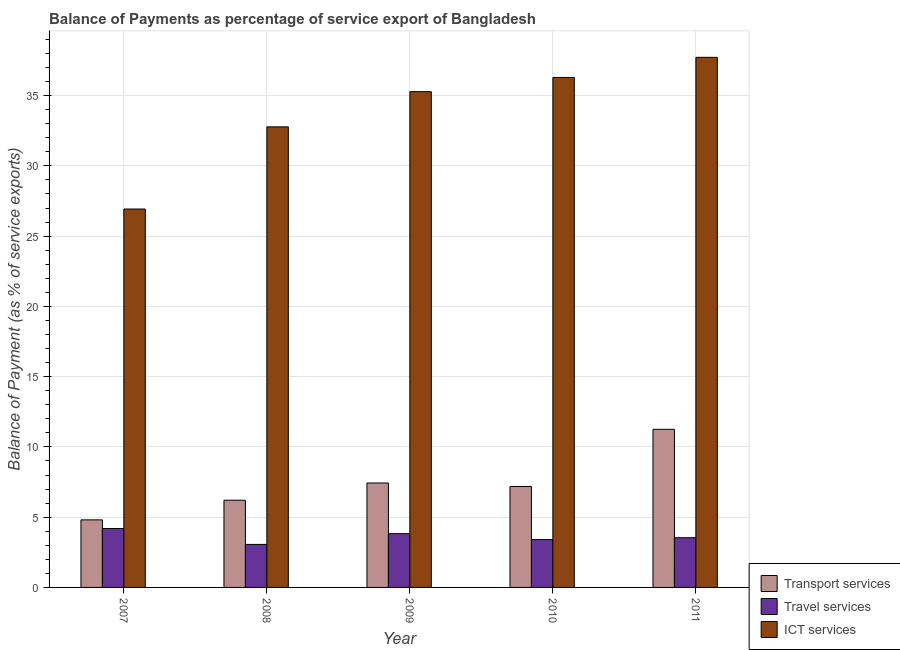Are the number of bars per tick equal to the number of legend labels?
Keep it short and to the point. Yes. How many bars are there on the 2nd tick from the left?
Your answer should be compact. 3. In how many cases, is the number of bars for a given year not equal to the number of legend labels?
Provide a short and direct response. 0. What is the balance of payment of travel services in 2010?
Keep it short and to the point. 3.4. Across all years, what is the maximum balance of payment of ict services?
Offer a very short reply. 37.73. Across all years, what is the minimum balance of payment of transport services?
Provide a succinct answer. 4.81. In which year was the balance of payment of travel services maximum?
Your answer should be compact. 2007. In which year was the balance of payment of ict services minimum?
Your response must be concise. 2007. What is the total balance of payment of ict services in the graph?
Make the answer very short. 169.01. What is the difference between the balance of payment of ict services in 2009 and that in 2011?
Ensure brevity in your answer.  -2.44. What is the difference between the balance of payment of travel services in 2010 and the balance of payment of ict services in 2011?
Make the answer very short. -0.13. What is the average balance of payment of ict services per year?
Your answer should be very brief. 33.8. In the year 2007, what is the difference between the balance of payment of ict services and balance of payment of travel services?
Provide a succinct answer. 0. In how many years, is the balance of payment of ict services greater than 33 %?
Provide a succinct answer. 3. What is the ratio of the balance of payment of transport services in 2008 to that in 2011?
Ensure brevity in your answer.  0.55. Is the difference between the balance of payment of transport services in 2007 and 2009 greater than the difference between the balance of payment of travel services in 2007 and 2009?
Make the answer very short. No. What is the difference between the highest and the second highest balance of payment of ict services?
Your response must be concise. 1.43. What is the difference between the highest and the lowest balance of payment of transport services?
Keep it short and to the point. 6.44. Is the sum of the balance of payment of ict services in 2007 and 2010 greater than the maximum balance of payment of travel services across all years?
Offer a very short reply. Yes. What does the 2nd bar from the left in 2009 represents?
Give a very brief answer. Travel services. What does the 2nd bar from the right in 2009 represents?
Your response must be concise. Travel services. How many years are there in the graph?
Provide a short and direct response. 5. Are the values on the major ticks of Y-axis written in scientific E-notation?
Provide a short and direct response. No. Does the graph contain any zero values?
Provide a succinct answer. No. Does the graph contain grids?
Your response must be concise. Yes. How many legend labels are there?
Offer a very short reply. 3. What is the title of the graph?
Your answer should be very brief. Balance of Payments as percentage of service export of Bangladesh. What is the label or title of the X-axis?
Your answer should be very brief. Year. What is the label or title of the Y-axis?
Keep it short and to the point. Balance of Payment (as % of service exports). What is the Balance of Payment (as % of service exports) in Transport services in 2007?
Your answer should be compact. 4.81. What is the Balance of Payment (as % of service exports) of Travel services in 2007?
Provide a short and direct response. 4.19. What is the Balance of Payment (as % of service exports) in ICT services in 2007?
Provide a short and direct response. 26.93. What is the Balance of Payment (as % of service exports) in Transport services in 2008?
Your answer should be very brief. 6.21. What is the Balance of Payment (as % of service exports) of Travel services in 2008?
Ensure brevity in your answer.  3.06. What is the Balance of Payment (as % of service exports) in ICT services in 2008?
Your response must be concise. 32.78. What is the Balance of Payment (as % of service exports) in Transport services in 2009?
Keep it short and to the point. 7.43. What is the Balance of Payment (as % of service exports) of Travel services in 2009?
Your answer should be compact. 3.83. What is the Balance of Payment (as % of service exports) of ICT services in 2009?
Give a very brief answer. 35.28. What is the Balance of Payment (as % of service exports) in Transport services in 2010?
Your answer should be compact. 7.19. What is the Balance of Payment (as % of service exports) in Travel services in 2010?
Ensure brevity in your answer.  3.4. What is the Balance of Payment (as % of service exports) in ICT services in 2010?
Make the answer very short. 36.29. What is the Balance of Payment (as % of service exports) in Transport services in 2011?
Keep it short and to the point. 11.25. What is the Balance of Payment (as % of service exports) in Travel services in 2011?
Give a very brief answer. 3.54. What is the Balance of Payment (as % of service exports) in ICT services in 2011?
Provide a succinct answer. 37.73. Across all years, what is the maximum Balance of Payment (as % of service exports) of Transport services?
Give a very brief answer. 11.25. Across all years, what is the maximum Balance of Payment (as % of service exports) of Travel services?
Provide a succinct answer. 4.19. Across all years, what is the maximum Balance of Payment (as % of service exports) of ICT services?
Your answer should be compact. 37.73. Across all years, what is the minimum Balance of Payment (as % of service exports) of Transport services?
Make the answer very short. 4.81. Across all years, what is the minimum Balance of Payment (as % of service exports) in Travel services?
Provide a short and direct response. 3.06. Across all years, what is the minimum Balance of Payment (as % of service exports) of ICT services?
Ensure brevity in your answer.  26.93. What is the total Balance of Payment (as % of service exports) of Transport services in the graph?
Your response must be concise. 36.88. What is the total Balance of Payment (as % of service exports) of Travel services in the graph?
Your response must be concise. 18.02. What is the total Balance of Payment (as % of service exports) in ICT services in the graph?
Make the answer very short. 169.01. What is the difference between the Balance of Payment (as % of service exports) in Transport services in 2007 and that in 2008?
Offer a very short reply. -1.4. What is the difference between the Balance of Payment (as % of service exports) in Travel services in 2007 and that in 2008?
Offer a terse response. 1.13. What is the difference between the Balance of Payment (as % of service exports) of ICT services in 2007 and that in 2008?
Provide a short and direct response. -5.85. What is the difference between the Balance of Payment (as % of service exports) of Transport services in 2007 and that in 2009?
Keep it short and to the point. -2.62. What is the difference between the Balance of Payment (as % of service exports) of Travel services in 2007 and that in 2009?
Offer a terse response. 0.37. What is the difference between the Balance of Payment (as % of service exports) in ICT services in 2007 and that in 2009?
Provide a short and direct response. -8.35. What is the difference between the Balance of Payment (as % of service exports) of Transport services in 2007 and that in 2010?
Offer a terse response. -2.38. What is the difference between the Balance of Payment (as % of service exports) of Travel services in 2007 and that in 2010?
Keep it short and to the point. 0.79. What is the difference between the Balance of Payment (as % of service exports) of ICT services in 2007 and that in 2010?
Keep it short and to the point. -9.37. What is the difference between the Balance of Payment (as % of service exports) of Transport services in 2007 and that in 2011?
Your response must be concise. -6.45. What is the difference between the Balance of Payment (as % of service exports) in Travel services in 2007 and that in 2011?
Ensure brevity in your answer.  0.66. What is the difference between the Balance of Payment (as % of service exports) of ICT services in 2007 and that in 2011?
Provide a succinct answer. -10.8. What is the difference between the Balance of Payment (as % of service exports) of Transport services in 2008 and that in 2009?
Offer a very short reply. -1.23. What is the difference between the Balance of Payment (as % of service exports) of Travel services in 2008 and that in 2009?
Give a very brief answer. -0.77. What is the difference between the Balance of Payment (as % of service exports) in ICT services in 2008 and that in 2009?
Offer a very short reply. -2.51. What is the difference between the Balance of Payment (as % of service exports) in Transport services in 2008 and that in 2010?
Ensure brevity in your answer.  -0.98. What is the difference between the Balance of Payment (as % of service exports) in Travel services in 2008 and that in 2010?
Ensure brevity in your answer.  -0.34. What is the difference between the Balance of Payment (as % of service exports) in ICT services in 2008 and that in 2010?
Offer a terse response. -3.52. What is the difference between the Balance of Payment (as % of service exports) of Transport services in 2008 and that in 2011?
Provide a succinct answer. -5.05. What is the difference between the Balance of Payment (as % of service exports) in Travel services in 2008 and that in 2011?
Your answer should be compact. -0.48. What is the difference between the Balance of Payment (as % of service exports) of ICT services in 2008 and that in 2011?
Ensure brevity in your answer.  -4.95. What is the difference between the Balance of Payment (as % of service exports) of Transport services in 2009 and that in 2010?
Your answer should be compact. 0.25. What is the difference between the Balance of Payment (as % of service exports) of Travel services in 2009 and that in 2010?
Make the answer very short. 0.42. What is the difference between the Balance of Payment (as % of service exports) in ICT services in 2009 and that in 2010?
Provide a short and direct response. -1.01. What is the difference between the Balance of Payment (as % of service exports) of Transport services in 2009 and that in 2011?
Provide a short and direct response. -3.82. What is the difference between the Balance of Payment (as % of service exports) in Travel services in 2009 and that in 2011?
Ensure brevity in your answer.  0.29. What is the difference between the Balance of Payment (as % of service exports) of ICT services in 2009 and that in 2011?
Give a very brief answer. -2.44. What is the difference between the Balance of Payment (as % of service exports) of Transport services in 2010 and that in 2011?
Your answer should be very brief. -4.07. What is the difference between the Balance of Payment (as % of service exports) of Travel services in 2010 and that in 2011?
Make the answer very short. -0.13. What is the difference between the Balance of Payment (as % of service exports) of ICT services in 2010 and that in 2011?
Provide a short and direct response. -1.43. What is the difference between the Balance of Payment (as % of service exports) of Transport services in 2007 and the Balance of Payment (as % of service exports) of Travel services in 2008?
Provide a succinct answer. 1.75. What is the difference between the Balance of Payment (as % of service exports) in Transport services in 2007 and the Balance of Payment (as % of service exports) in ICT services in 2008?
Provide a short and direct response. -27.97. What is the difference between the Balance of Payment (as % of service exports) of Travel services in 2007 and the Balance of Payment (as % of service exports) of ICT services in 2008?
Your answer should be very brief. -28.58. What is the difference between the Balance of Payment (as % of service exports) in Transport services in 2007 and the Balance of Payment (as % of service exports) in Travel services in 2009?
Your response must be concise. 0.98. What is the difference between the Balance of Payment (as % of service exports) of Transport services in 2007 and the Balance of Payment (as % of service exports) of ICT services in 2009?
Your answer should be compact. -30.48. What is the difference between the Balance of Payment (as % of service exports) of Travel services in 2007 and the Balance of Payment (as % of service exports) of ICT services in 2009?
Offer a terse response. -31.09. What is the difference between the Balance of Payment (as % of service exports) in Transport services in 2007 and the Balance of Payment (as % of service exports) in Travel services in 2010?
Offer a very short reply. 1.4. What is the difference between the Balance of Payment (as % of service exports) of Transport services in 2007 and the Balance of Payment (as % of service exports) of ICT services in 2010?
Offer a very short reply. -31.49. What is the difference between the Balance of Payment (as % of service exports) in Travel services in 2007 and the Balance of Payment (as % of service exports) in ICT services in 2010?
Provide a succinct answer. -32.1. What is the difference between the Balance of Payment (as % of service exports) of Transport services in 2007 and the Balance of Payment (as % of service exports) of Travel services in 2011?
Your answer should be compact. 1.27. What is the difference between the Balance of Payment (as % of service exports) in Transport services in 2007 and the Balance of Payment (as % of service exports) in ICT services in 2011?
Your answer should be very brief. -32.92. What is the difference between the Balance of Payment (as % of service exports) in Travel services in 2007 and the Balance of Payment (as % of service exports) in ICT services in 2011?
Offer a terse response. -33.53. What is the difference between the Balance of Payment (as % of service exports) in Transport services in 2008 and the Balance of Payment (as % of service exports) in Travel services in 2009?
Your answer should be very brief. 2.38. What is the difference between the Balance of Payment (as % of service exports) in Transport services in 2008 and the Balance of Payment (as % of service exports) in ICT services in 2009?
Offer a terse response. -29.08. What is the difference between the Balance of Payment (as % of service exports) in Travel services in 2008 and the Balance of Payment (as % of service exports) in ICT services in 2009?
Offer a terse response. -32.22. What is the difference between the Balance of Payment (as % of service exports) of Transport services in 2008 and the Balance of Payment (as % of service exports) of Travel services in 2010?
Offer a terse response. 2.8. What is the difference between the Balance of Payment (as % of service exports) of Transport services in 2008 and the Balance of Payment (as % of service exports) of ICT services in 2010?
Give a very brief answer. -30.09. What is the difference between the Balance of Payment (as % of service exports) in Travel services in 2008 and the Balance of Payment (as % of service exports) in ICT services in 2010?
Make the answer very short. -33.23. What is the difference between the Balance of Payment (as % of service exports) in Transport services in 2008 and the Balance of Payment (as % of service exports) in Travel services in 2011?
Keep it short and to the point. 2.67. What is the difference between the Balance of Payment (as % of service exports) in Transport services in 2008 and the Balance of Payment (as % of service exports) in ICT services in 2011?
Your answer should be compact. -31.52. What is the difference between the Balance of Payment (as % of service exports) of Travel services in 2008 and the Balance of Payment (as % of service exports) of ICT services in 2011?
Make the answer very short. -34.66. What is the difference between the Balance of Payment (as % of service exports) in Transport services in 2009 and the Balance of Payment (as % of service exports) in Travel services in 2010?
Offer a very short reply. 4.03. What is the difference between the Balance of Payment (as % of service exports) in Transport services in 2009 and the Balance of Payment (as % of service exports) in ICT services in 2010?
Provide a short and direct response. -28.86. What is the difference between the Balance of Payment (as % of service exports) of Travel services in 2009 and the Balance of Payment (as % of service exports) of ICT services in 2010?
Make the answer very short. -32.47. What is the difference between the Balance of Payment (as % of service exports) of Transport services in 2009 and the Balance of Payment (as % of service exports) of Travel services in 2011?
Your response must be concise. 3.9. What is the difference between the Balance of Payment (as % of service exports) in Transport services in 2009 and the Balance of Payment (as % of service exports) in ICT services in 2011?
Ensure brevity in your answer.  -30.29. What is the difference between the Balance of Payment (as % of service exports) of Travel services in 2009 and the Balance of Payment (as % of service exports) of ICT services in 2011?
Give a very brief answer. -33.9. What is the difference between the Balance of Payment (as % of service exports) of Transport services in 2010 and the Balance of Payment (as % of service exports) of Travel services in 2011?
Give a very brief answer. 3.65. What is the difference between the Balance of Payment (as % of service exports) in Transport services in 2010 and the Balance of Payment (as % of service exports) in ICT services in 2011?
Offer a very short reply. -30.54. What is the difference between the Balance of Payment (as % of service exports) in Travel services in 2010 and the Balance of Payment (as % of service exports) in ICT services in 2011?
Make the answer very short. -34.32. What is the average Balance of Payment (as % of service exports) in Transport services per year?
Ensure brevity in your answer.  7.38. What is the average Balance of Payment (as % of service exports) in Travel services per year?
Give a very brief answer. 3.6. What is the average Balance of Payment (as % of service exports) in ICT services per year?
Give a very brief answer. 33.8. In the year 2007, what is the difference between the Balance of Payment (as % of service exports) in Transport services and Balance of Payment (as % of service exports) in Travel services?
Your answer should be compact. 0.62. In the year 2007, what is the difference between the Balance of Payment (as % of service exports) in Transport services and Balance of Payment (as % of service exports) in ICT services?
Make the answer very short. -22.12. In the year 2007, what is the difference between the Balance of Payment (as % of service exports) of Travel services and Balance of Payment (as % of service exports) of ICT services?
Ensure brevity in your answer.  -22.74. In the year 2008, what is the difference between the Balance of Payment (as % of service exports) in Transport services and Balance of Payment (as % of service exports) in Travel services?
Provide a short and direct response. 3.14. In the year 2008, what is the difference between the Balance of Payment (as % of service exports) of Transport services and Balance of Payment (as % of service exports) of ICT services?
Make the answer very short. -26.57. In the year 2008, what is the difference between the Balance of Payment (as % of service exports) in Travel services and Balance of Payment (as % of service exports) in ICT services?
Your response must be concise. -29.72. In the year 2009, what is the difference between the Balance of Payment (as % of service exports) of Transport services and Balance of Payment (as % of service exports) of Travel services?
Your answer should be very brief. 3.61. In the year 2009, what is the difference between the Balance of Payment (as % of service exports) in Transport services and Balance of Payment (as % of service exports) in ICT services?
Give a very brief answer. -27.85. In the year 2009, what is the difference between the Balance of Payment (as % of service exports) in Travel services and Balance of Payment (as % of service exports) in ICT services?
Offer a terse response. -31.46. In the year 2010, what is the difference between the Balance of Payment (as % of service exports) in Transport services and Balance of Payment (as % of service exports) in Travel services?
Offer a terse response. 3.78. In the year 2010, what is the difference between the Balance of Payment (as % of service exports) in Transport services and Balance of Payment (as % of service exports) in ICT services?
Keep it short and to the point. -29.11. In the year 2010, what is the difference between the Balance of Payment (as % of service exports) in Travel services and Balance of Payment (as % of service exports) in ICT services?
Provide a succinct answer. -32.89. In the year 2011, what is the difference between the Balance of Payment (as % of service exports) of Transport services and Balance of Payment (as % of service exports) of Travel services?
Provide a short and direct response. 7.72. In the year 2011, what is the difference between the Balance of Payment (as % of service exports) in Transport services and Balance of Payment (as % of service exports) in ICT services?
Keep it short and to the point. -26.47. In the year 2011, what is the difference between the Balance of Payment (as % of service exports) in Travel services and Balance of Payment (as % of service exports) in ICT services?
Your answer should be compact. -34.19. What is the ratio of the Balance of Payment (as % of service exports) of Transport services in 2007 to that in 2008?
Your answer should be very brief. 0.77. What is the ratio of the Balance of Payment (as % of service exports) of Travel services in 2007 to that in 2008?
Ensure brevity in your answer.  1.37. What is the ratio of the Balance of Payment (as % of service exports) of ICT services in 2007 to that in 2008?
Offer a very short reply. 0.82. What is the ratio of the Balance of Payment (as % of service exports) of Transport services in 2007 to that in 2009?
Offer a very short reply. 0.65. What is the ratio of the Balance of Payment (as % of service exports) of Travel services in 2007 to that in 2009?
Your response must be concise. 1.1. What is the ratio of the Balance of Payment (as % of service exports) in ICT services in 2007 to that in 2009?
Your response must be concise. 0.76. What is the ratio of the Balance of Payment (as % of service exports) of Transport services in 2007 to that in 2010?
Offer a very short reply. 0.67. What is the ratio of the Balance of Payment (as % of service exports) of Travel services in 2007 to that in 2010?
Give a very brief answer. 1.23. What is the ratio of the Balance of Payment (as % of service exports) of ICT services in 2007 to that in 2010?
Offer a very short reply. 0.74. What is the ratio of the Balance of Payment (as % of service exports) of Transport services in 2007 to that in 2011?
Ensure brevity in your answer.  0.43. What is the ratio of the Balance of Payment (as % of service exports) in Travel services in 2007 to that in 2011?
Your response must be concise. 1.19. What is the ratio of the Balance of Payment (as % of service exports) of ICT services in 2007 to that in 2011?
Make the answer very short. 0.71. What is the ratio of the Balance of Payment (as % of service exports) of Transport services in 2008 to that in 2009?
Your answer should be very brief. 0.83. What is the ratio of the Balance of Payment (as % of service exports) of Travel services in 2008 to that in 2009?
Ensure brevity in your answer.  0.8. What is the ratio of the Balance of Payment (as % of service exports) of ICT services in 2008 to that in 2009?
Give a very brief answer. 0.93. What is the ratio of the Balance of Payment (as % of service exports) of Transport services in 2008 to that in 2010?
Your response must be concise. 0.86. What is the ratio of the Balance of Payment (as % of service exports) in Travel services in 2008 to that in 2010?
Make the answer very short. 0.9. What is the ratio of the Balance of Payment (as % of service exports) in ICT services in 2008 to that in 2010?
Offer a terse response. 0.9. What is the ratio of the Balance of Payment (as % of service exports) of Transport services in 2008 to that in 2011?
Offer a very short reply. 0.55. What is the ratio of the Balance of Payment (as % of service exports) of Travel services in 2008 to that in 2011?
Ensure brevity in your answer.  0.87. What is the ratio of the Balance of Payment (as % of service exports) in ICT services in 2008 to that in 2011?
Provide a succinct answer. 0.87. What is the ratio of the Balance of Payment (as % of service exports) of Transport services in 2009 to that in 2010?
Provide a short and direct response. 1.03. What is the ratio of the Balance of Payment (as % of service exports) in Travel services in 2009 to that in 2010?
Your answer should be compact. 1.12. What is the ratio of the Balance of Payment (as % of service exports) of ICT services in 2009 to that in 2010?
Keep it short and to the point. 0.97. What is the ratio of the Balance of Payment (as % of service exports) in Transport services in 2009 to that in 2011?
Provide a short and direct response. 0.66. What is the ratio of the Balance of Payment (as % of service exports) of Travel services in 2009 to that in 2011?
Ensure brevity in your answer.  1.08. What is the ratio of the Balance of Payment (as % of service exports) of ICT services in 2009 to that in 2011?
Your answer should be compact. 0.94. What is the ratio of the Balance of Payment (as % of service exports) of Transport services in 2010 to that in 2011?
Your response must be concise. 0.64. What is the ratio of the Balance of Payment (as % of service exports) in Travel services in 2010 to that in 2011?
Your response must be concise. 0.96. What is the ratio of the Balance of Payment (as % of service exports) of ICT services in 2010 to that in 2011?
Offer a terse response. 0.96. What is the difference between the highest and the second highest Balance of Payment (as % of service exports) of Transport services?
Make the answer very short. 3.82. What is the difference between the highest and the second highest Balance of Payment (as % of service exports) of Travel services?
Provide a short and direct response. 0.37. What is the difference between the highest and the second highest Balance of Payment (as % of service exports) of ICT services?
Your answer should be very brief. 1.43. What is the difference between the highest and the lowest Balance of Payment (as % of service exports) in Transport services?
Provide a short and direct response. 6.45. What is the difference between the highest and the lowest Balance of Payment (as % of service exports) in Travel services?
Ensure brevity in your answer.  1.13. What is the difference between the highest and the lowest Balance of Payment (as % of service exports) of ICT services?
Give a very brief answer. 10.8. 